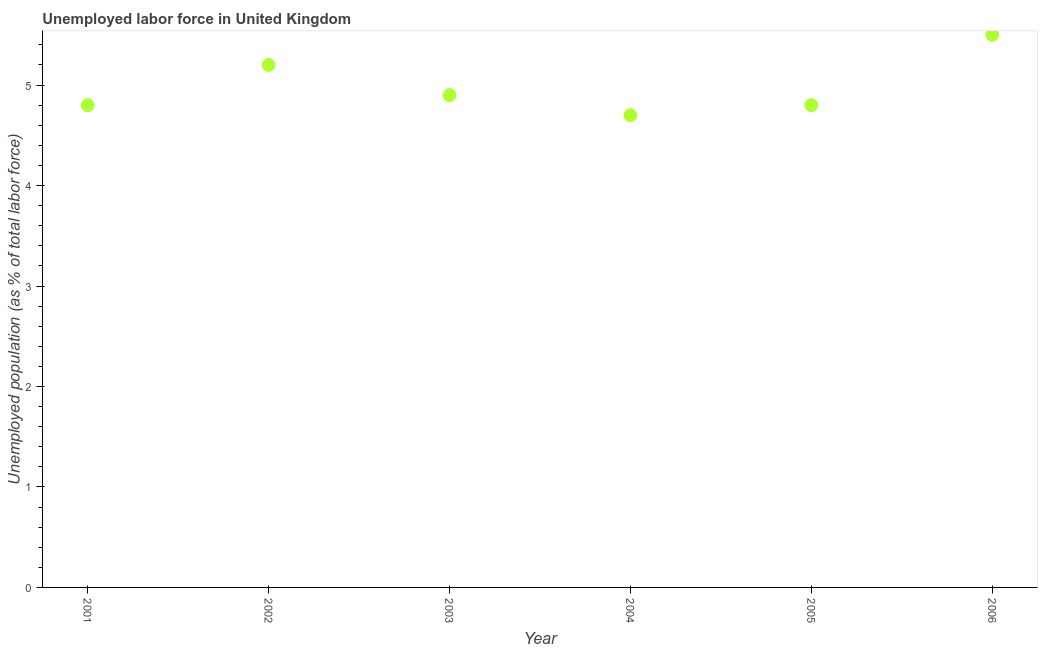What is the total unemployed population in 2005?
Provide a short and direct response. 4.8. Across all years, what is the maximum total unemployed population?
Make the answer very short. 5.5. Across all years, what is the minimum total unemployed population?
Give a very brief answer. 4.7. In which year was the total unemployed population maximum?
Give a very brief answer. 2006. What is the sum of the total unemployed population?
Your answer should be very brief. 29.9. What is the difference between the total unemployed population in 2002 and 2005?
Offer a terse response. 0.4. What is the average total unemployed population per year?
Ensure brevity in your answer.  4.98. What is the median total unemployed population?
Make the answer very short. 4.85. In how many years, is the total unemployed population greater than 3.2 %?
Your response must be concise. 6. What is the ratio of the total unemployed population in 2004 to that in 2006?
Keep it short and to the point. 0.85. Is the difference between the total unemployed population in 2001 and 2005 greater than the difference between any two years?
Make the answer very short. No. What is the difference between the highest and the second highest total unemployed population?
Provide a short and direct response. 0.3. Is the sum of the total unemployed population in 2001 and 2002 greater than the maximum total unemployed population across all years?
Your response must be concise. Yes. What is the difference between the highest and the lowest total unemployed population?
Make the answer very short. 0.8. Are the values on the major ticks of Y-axis written in scientific E-notation?
Your response must be concise. No. Does the graph contain grids?
Offer a terse response. No. What is the title of the graph?
Provide a short and direct response. Unemployed labor force in United Kingdom. What is the label or title of the Y-axis?
Ensure brevity in your answer.  Unemployed population (as % of total labor force). What is the Unemployed population (as % of total labor force) in 2001?
Offer a terse response. 4.8. What is the Unemployed population (as % of total labor force) in 2002?
Offer a terse response. 5.2. What is the Unemployed population (as % of total labor force) in 2003?
Offer a very short reply. 4.9. What is the Unemployed population (as % of total labor force) in 2004?
Offer a terse response. 4.7. What is the Unemployed population (as % of total labor force) in 2005?
Keep it short and to the point. 4.8. What is the Unemployed population (as % of total labor force) in 2006?
Your answer should be compact. 5.5. What is the difference between the Unemployed population (as % of total labor force) in 2001 and 2005?
Your answer should be very brief. 0. What is the difference between the Unemployed population (as % of total labor force) in 2001 and 2006?
Provide a short and direct response. -0.7. What is the difference between the Unemployed population (as % of total labor force) in 2002 and 2006?
Offer a very short reply. -0.3. What is the difference between the Unemployed population (as % of total labor force) in 2005 and 2006?
Ensure brevity in your answer.  -0.7. What is the ratio of the Unemployed population (as % of total labor force) in 2001 to that in 2002?
Offer a terse response. 0.92. What is the ratio of the Unemployed population (as % of total labor force) in 2001 to that in 2004?
Provide a short and direct response. 1.02. What is the ratio of the Unemployed population (as % of total labor force) in 2001 to that in 2006?
Your answer should be very brief. 0.87. What is the ratio of the Unemployed population (as % of total labor force) in 2002 to that in 2003?
Ensure brevity in your answer.  1.06. What is the ratio of the Unemployed population (as % of total labor force) in 2002 to that in 2004?
Provide a succinct answer. 1.11. What is the ratio of the Unemployed population (as % of total labor force) in 2002 to that in 2005?
Provide a short and direct response. 1.08. What is the ratio of the Unemployed population (as % of total labor force) in 2002 to that in 2006?
Your answer should be very brief. 0.94. What is the ratio of the Unemployed population (as % of total labor force) in 2003 to that in 2004?
Provide a succinct answer. 1.04. What is the ratio of the Unemployed population (as % of total labor force) in 2003 to that in 2005?
Your response must be concise. 1.02. What is the ratio of the Unemployed population (as % of total labor force) in 2003 to that in 2006?
Ensure brevity in your answer.  0.89. What is the ratio of the Unemployed population (as % of total labor force) in 2004 to that in 2005?
Provide a succinct answer. 0.98. What is the ratio of the Unemployed population (as % of total labor force) in 2004 to that in 2006?
Make the answer very short. 0.85. What is the ratio of the Unemployed population (as % of total labor force) in 2005 to that in 2006?
Offer a very short reply. 0.87. 